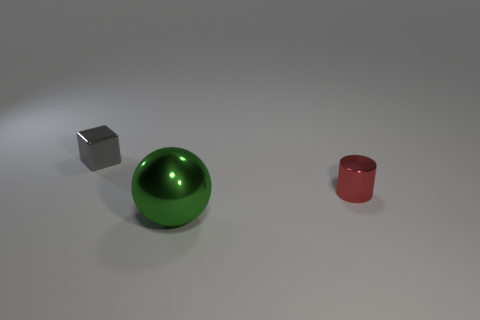Are there fewer shiny cubes that are on the right side of the large object than metallic objects that are to the left of the tiny cylinder? Yes, there is one shiny cube to the right of the large green sphere, which is fewer than the metallic objects located to the left of the small red cylinder. In this image, I only observe one metallic cube to the left, which would make the count equal rather than fewer. This means that the response may need clarification as 'fewer' indicates a comparability that doesn't exist in the observed scenario. The cube and the cylinder are distinct objects, not part of a larger group of similar items that can be directly compared in quantity. 